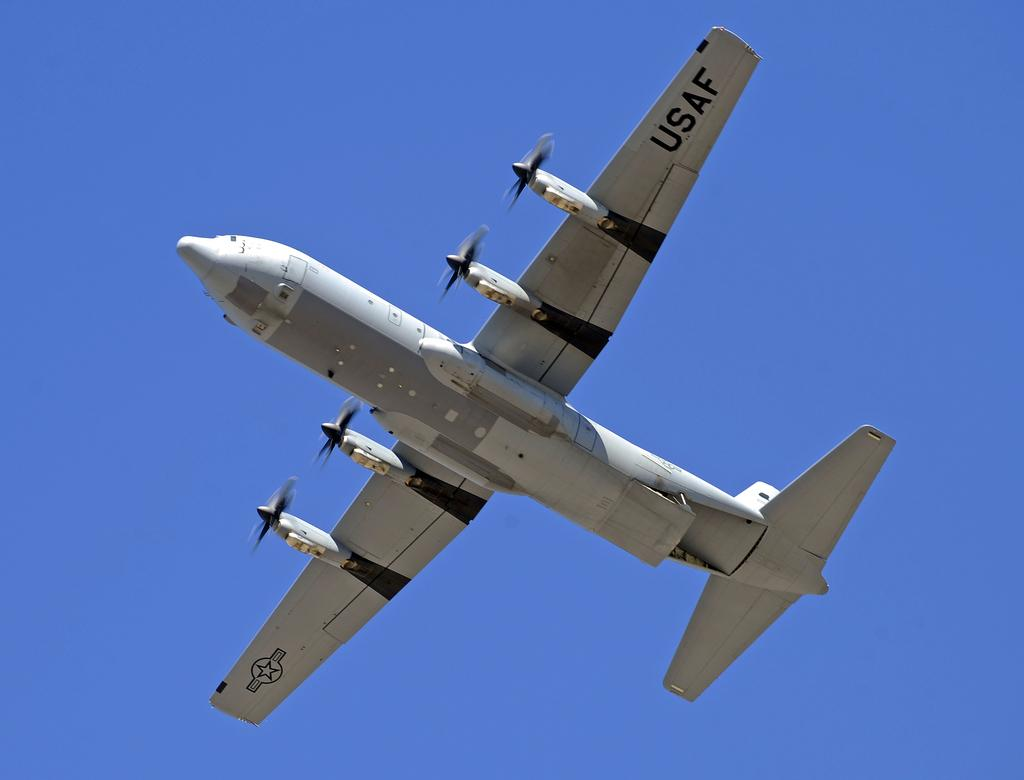<image>
Write a terse but informative summary of the picture. the under side of a usaf airplane in mid flight. 